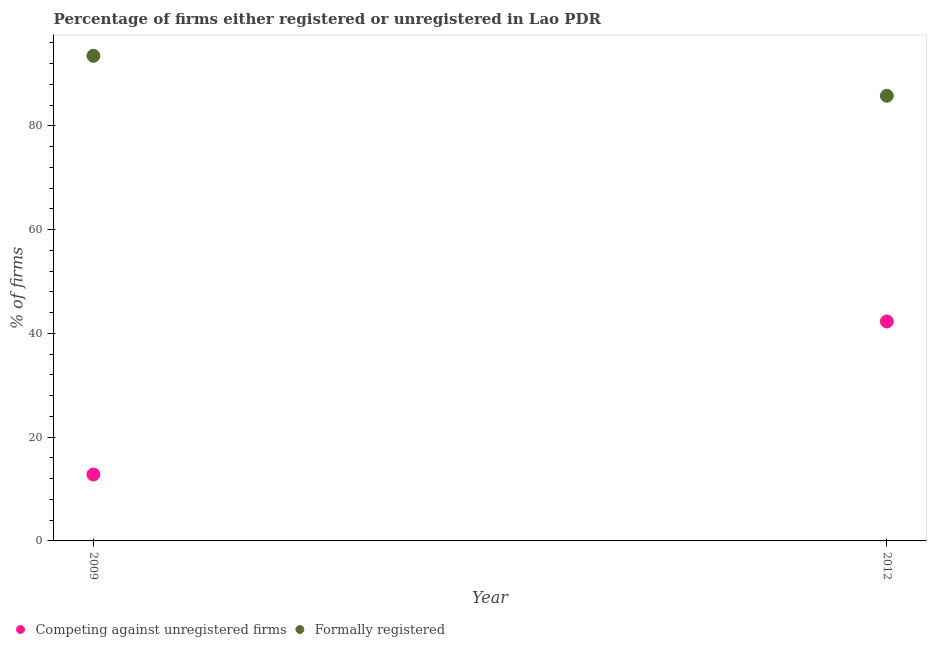What is the percentage of formally registered firms in 2012?
Offer a terse response. 85.8. Across all years, what is the maximum percentage of registered firms?
Make the answer very short. 42.3. Across all years, what is the minimum percentage of registered firms?
Provide a succinct answer. 12.8. In which year was the percentage of registered firms maximum?
Make the answer very short. 2012. In which year was the percentage of formally registered firms minimum?
Give a very brief answer. 2012. What is the total percentage of formally registered firms in the graph?
Give a very brief answer. 179.3. What is the difference between the percentage of registered firms in 2009 and that in 2012?
Offer a terse response. -29.5. What is the difference between the percentage of registered firms in 2012 and the percentage of formally registered firms in 2009?
Give a very brief answer. -51.2. What is the average percentage of formally registered firms per year?
Provide a short and direct response. 89.65. In the year 2009, what is the difference between the percentage of registered firms and percentage of formally registered firms?
Your response must be concise. -80.7. What is the ratio of the percentage of registered firms in 2009 to that in 2012?
Give a very brief answer. 0.3. Is the percentage of registered firms in 2009 less than that in 2012?
Your response must be concise. Yes. Does the percentage of formally registered firms monotonically increase over the years?
Your answer should be compact. No. Is the percentage of formally registered firms strictly less than the percentage of registered firms over the years?
Provide a succinct answer. No. How many dotlines are there?
Give a very brief answer. 2. How many years are there in the graph?
Provide a short and direct response. 2. Where does the legend appear in the graph?
Keep it short and to the point. Bottom left. How many legend labels are there?
Provide a succinct answer. 2. How are the legend labels stacked?
Offer a terse response. Horizontal. What is the title of the graph?
Keep it short and to the point. Percentage of firms either registered or unregistered in Lao PDR. Does "Highest 10% of population" appear as one of the legend labels in the graph?
Offer a very short reply. No. What is the label or title of the X-axis?
Offer a very short reply. Year. What is the label or title of the Y-axis?
Make the answer very short. % of firms. What is the % of firms of Competing against unregistered firms in 2009?
Your answer should be very brief. 12.8. What is the % of firms in Formally registered in 2009?
Provide a short and direct response. 93.5. What is the % of firms of Competing against unregistered firms in 2012?
Your answer should be very brief. 42.3. What is the % of firms of Formally registered in 2012?
Give a very brief answer. 85.8. Across all years, what is the maximum % of firms in Competing against unregistered firms?
Your response must be concise. 42.3. Across all years, what is the maximum % of firms of Formally registered?
Give a very brief answer. 93.5. Across all years, what is the minimum % of firms of Competing against unregistered firms?
Your response must be concise. 12.8. Across all years, what is the minimum % of firms in Formally registered?
Provide a short and direct response. 85.8. What is the total % of firms of Competing against unregistered firms in the graph?
Your answer should be very brief. 55.1. What is the total % of firms of Formally registered in the graph?
Ensure brevity in your answer.  179.3. What is the difference between the % of firms in Competing against unregistered firms in 2009 and that in 2012?
Ensure brevity in your answer.  -29.5. What is the difference between the % of firms in Competing against unregistered firms in 2009 and the % of firms in Formally registered in 2012?
Your response must be concise. -73. What is the average % of firms of Competing against unregistered firms per year?
Offer a terse response. 27.55. What is the average % of firms in Formally registered per year?
Your response must be concise. 89.65. In the year 2009, what is the difference between the % of firms in Competing against unregistered firms and % of firms in Formally registered?
Offer a terse response. -80.7. In the year 2012, what is the difference between the % of firms of Competing against unregistered firms and % of firms of Formally registered?
Your response must be concise. -43.5. What is the ratio of the % of firms of Competing against unregistered firms in 2009 to that in 2012?
Offer a very short reply. 0.3. What is the ratio of the % of firms in Formally registered in 2009 to that in 2012?
Ensure brevity in your answer.  1.09. What is the difference between the highest and the second highest % of firms in Competing against unregistered firms?
Provide a short and direct response. 29.5. What is the difference between the highest and the second highest % of firms in Formally registered?
Ensure brevity in your answer.  7.7. What is the difference between the highest and the lowest % of firms of Competing against unregistered firms?
Make the answer very short. 29.5. 